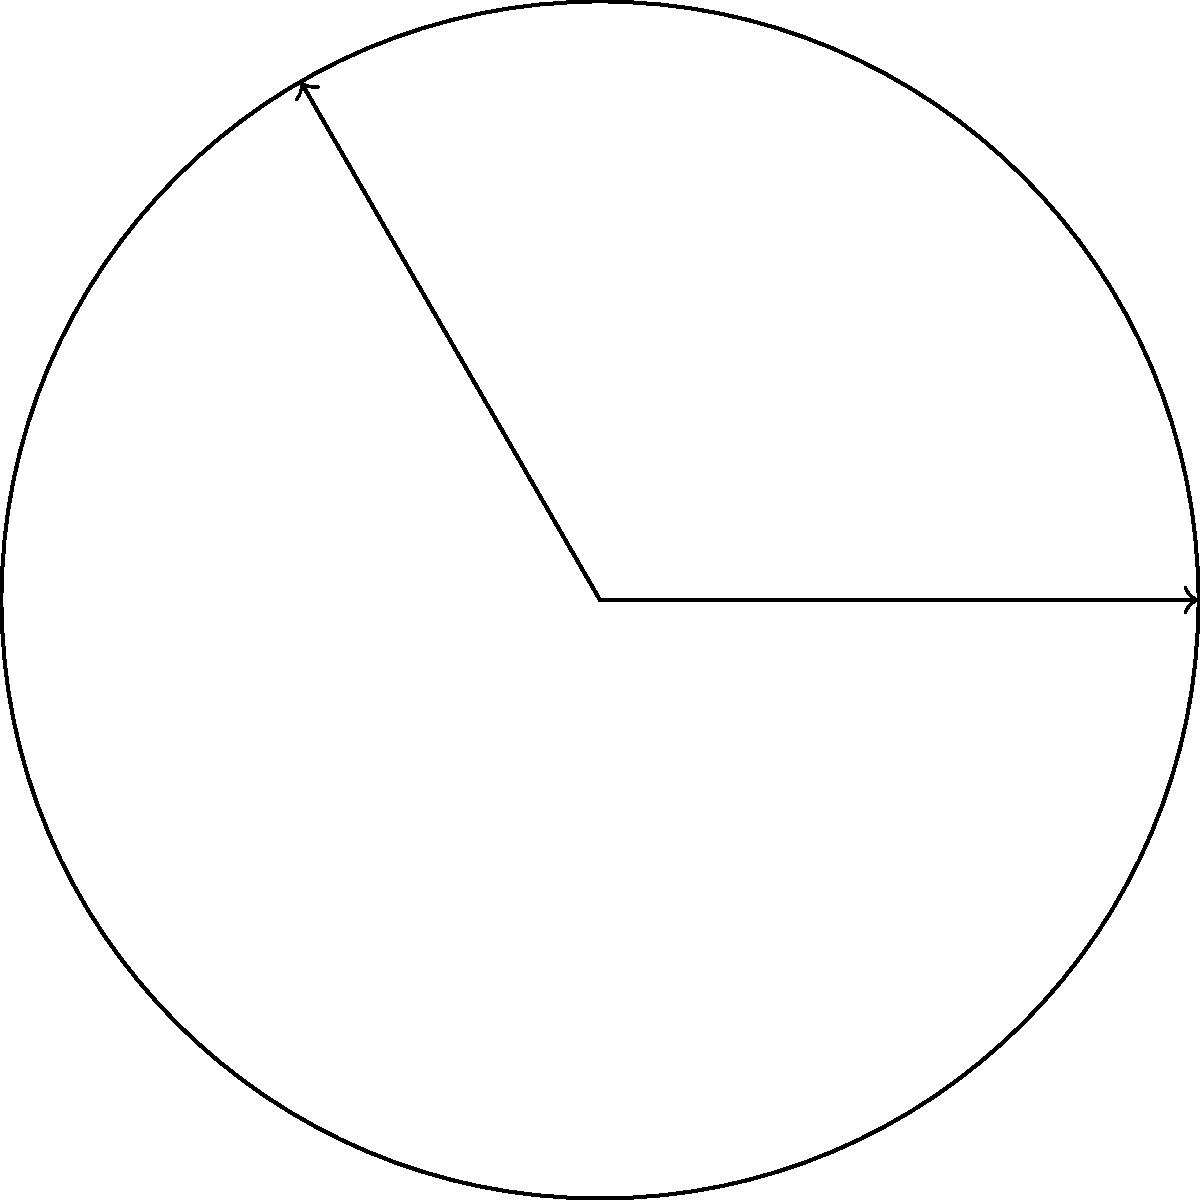In a circular sector, the radius $r$ is 15 cm and the central angle $\theta$ is $\frac{2\pi}{3}$ radians. Calculate the length of the arc AB to the nearest 0.01 cm. How might this calculation be relevant in designing curved components for advanced materials? To solve this problem, we'll use the formula for arc length and then relate it to materials science applications. Let's proceed step-by-step:

1) The formula for arc length $s$ is:
   $$s = r\theta$$
   where $r$ is the radius and $\theta$ is the central angle in radians.

2) We're given:
   $r = 15$ cm
   $\theta = \frac{2\pi}{3}$ radians

3) Substituting these values into the formula:
   $$s = 15 \cdot \frac{2\pi}{3}$$

4) Simplifying:
   $$s = 10\pi \approx 31.4159... \text{ cm}$$

5) Rounding to the nearest 0.01 cm:
   $$s \approx 31.42 \text{ cm}$$

Relevance to materials science:

This calculation is crucial in designing curved components for advanced materials. For instance:

1) In the development of flexible electronics, understanding arc lengths helps in designing curved displays or wearable devices that conform to body contours.

2) For composite materials used in aerospace, precise arc length calculations are essential for creating curved structural components that maintain strength and integrity.

3) In nanotechnology, arc length calculations at the microscale are vital for designing curved nanostructures or analyzing the bending of nanotubes.

4) For biomaterials, such calculations aid in designing implants or prosthetics that match the curvature of bones or organs.

Understanding these geometric principles allows materials scientists to optimize designs for specific applications, ensuring functionality, durability, and efficiency in advanced materials and structures.
Answer: 31.42 cm 